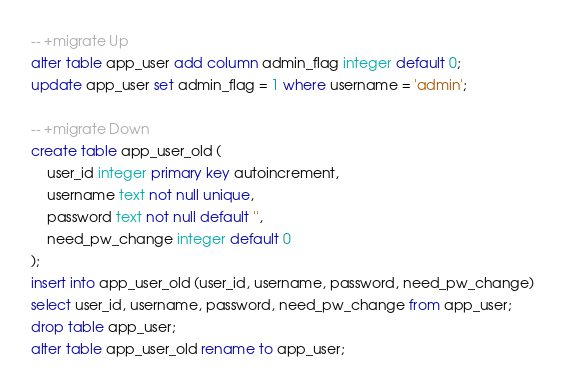Convert code to text. <code><loc_0><loc_0><loc_500><loc_500><_SQL_>
-- +migrate Up
alter table app_user add column admin_flag integer default 0;
update app_user set admin_flag = 1 where username = 'admin';

-- +migrate Down
create table app_user_old (
    user_id integer primary key autoincrement,
    username text not null unique,
    password text not null default '',
    need_pw_change integer default 0
);
insert into app_user_old (user_id, username, password, need_pw_change)
select user_id, username, password, need_pw_change from app_user;
drop table app_user;
alter table app_user_old rename to app_user;</code> 